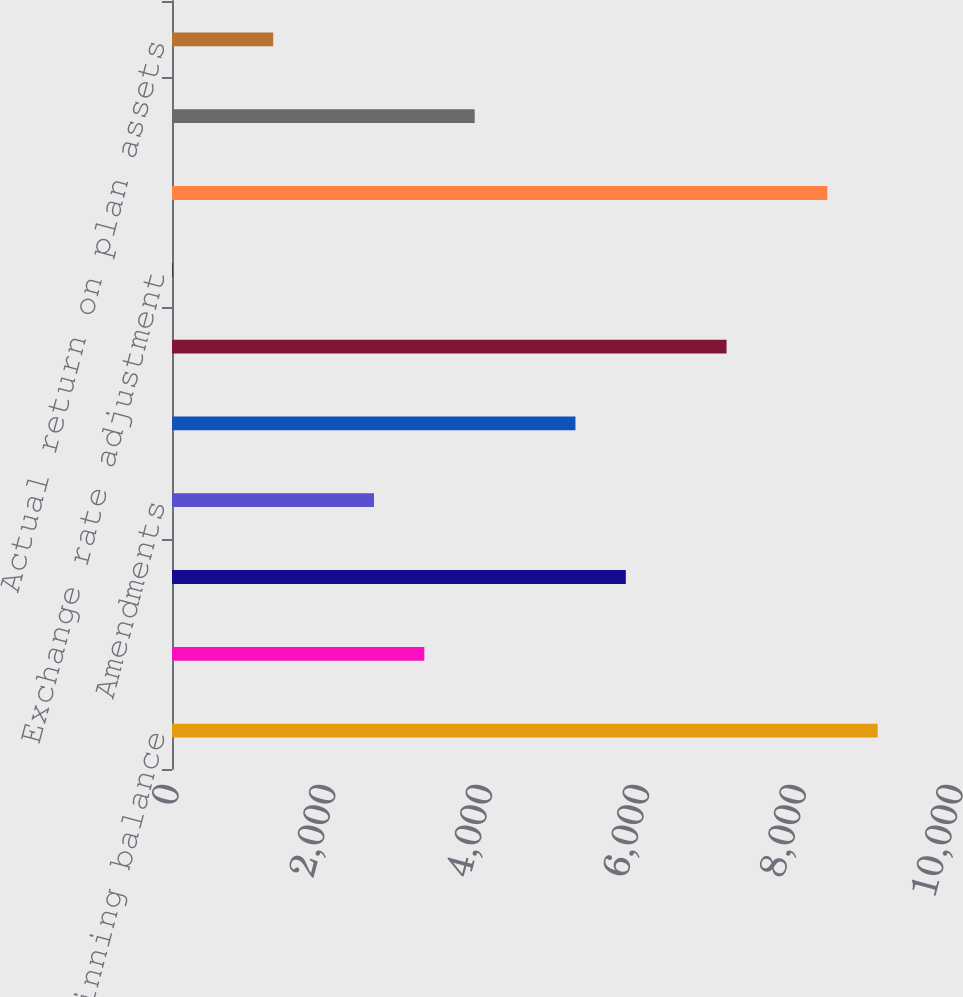Convert chart. <chart><loc_0><loc_0><loc_500><loc_500><bar_chart><fcel>Beginning balance<fcel>Service cost<fcel>Interest cost<fcel>Amendments<fcel>Actuarial loss/(gain)<fcel>Gross benefits paid<fcel>Exchange rate adjustment<fcel>Ending balance<fcel>Beginning balance at fair<fcel>Actual return on plan assets<nl><fcel>9001<fcel>3218.5<fcel>5788.5<fcel>2576<fcel>5146<fcel>7073.5<fcel>6<fcel>8358.5<fcel>3861<fcel>1291<nl></chart> 